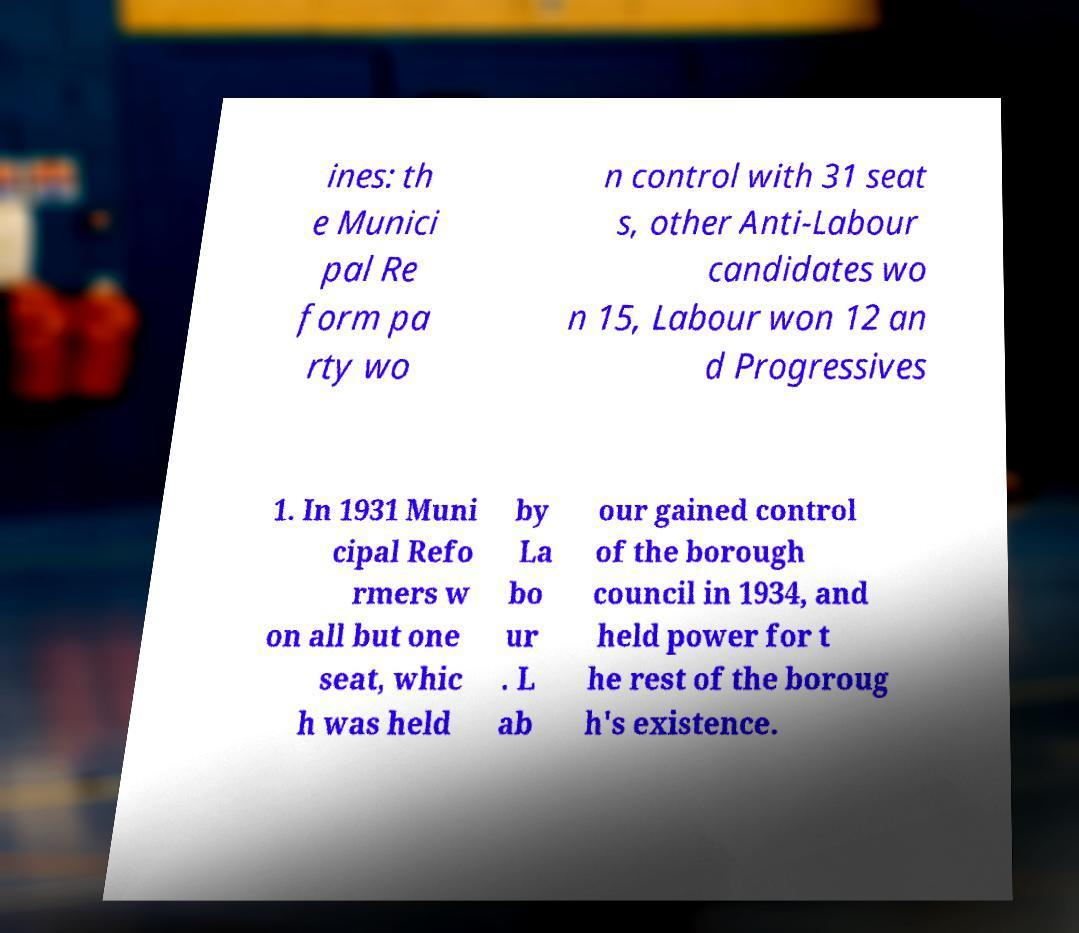I need the written content from this picture converted into text. Can you do that? ines: th e Munici pal Re form pa rty wo n control with 31 seat s, other Anti-Labour candidates wo n 15, Labour won 12 an d Progressives 1. In 1931 Muni cipal Refo rmers w on all but one seat, whic h was held by La bo ur . L ab our gained control of the borough council in 1934, and held power for t he rest of the boroug h's existence. 